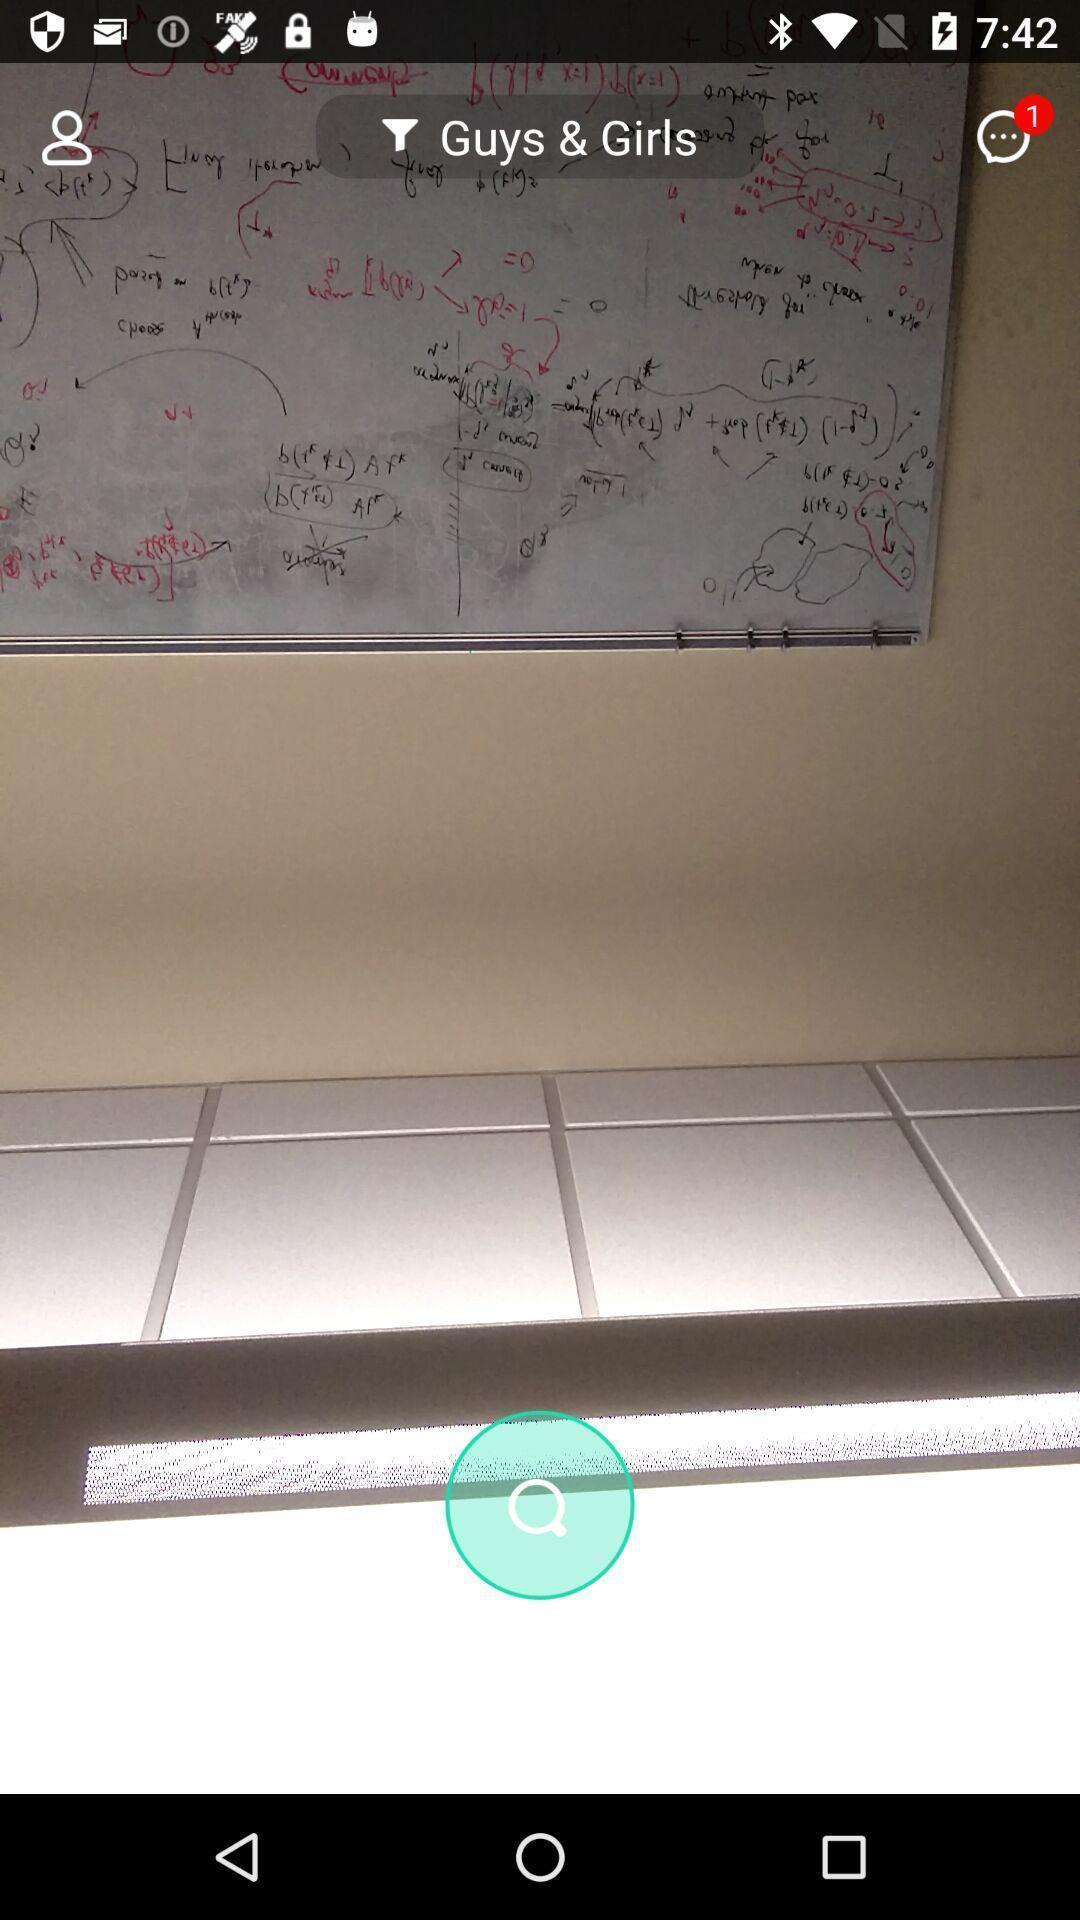Provide a description of this screenshot. Search page for searching in an image of dating app. 